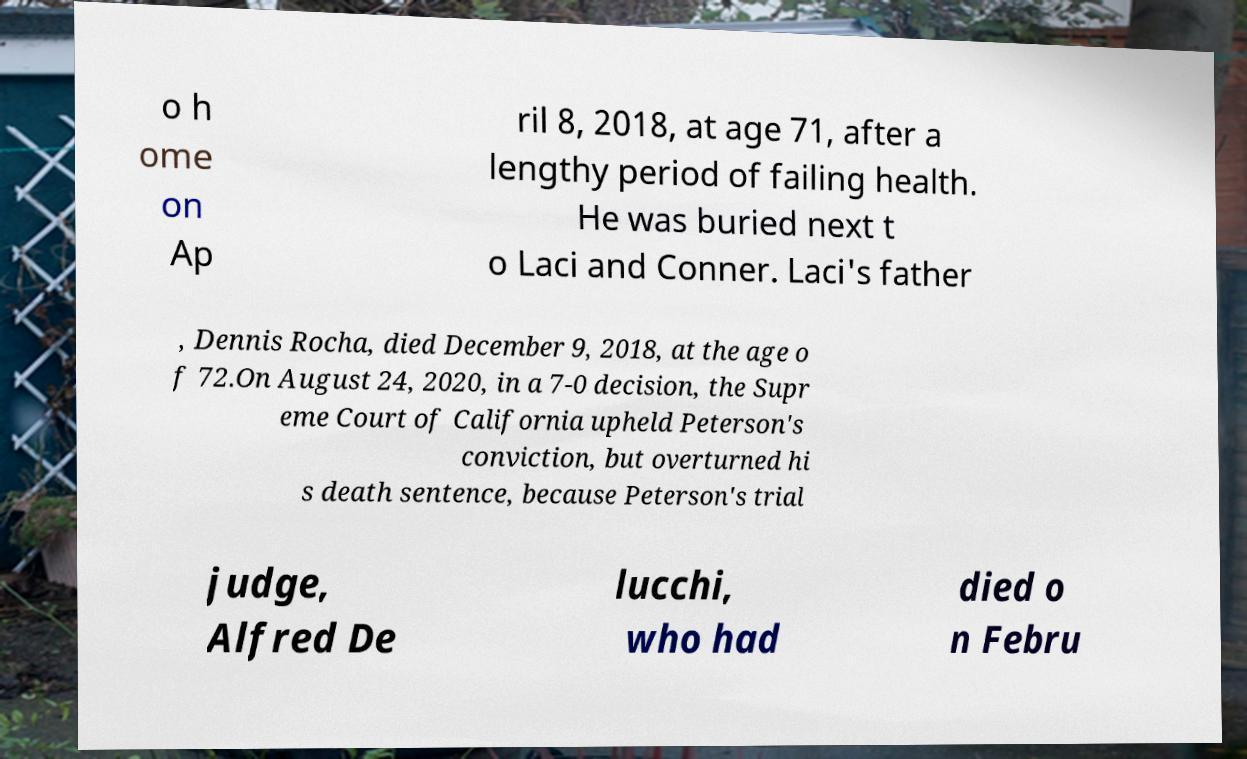Please identify and transcribe the text found in this image. o h ome on Ap ril 8, 2018, at age 71, after a lengthy period of failing health. He was buried next t o Laci and Conner. Laci's father , Dennis Rocha, died December 9, 2018, at the age o f 72.On August 24, 2020, in a 7-0 decision, the Supr eme Court of California upheld Peterson's conviction, but overturned hi s death sentence, because Peterson's trial judge, Alfred De lucchi, who had died o n Febru 